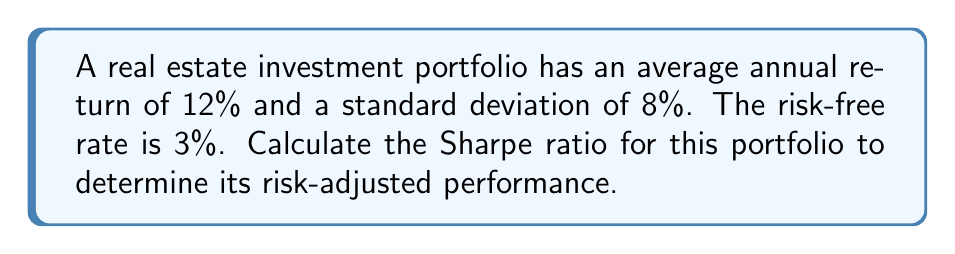Give your solution to this math problem. To calculate the Sharpe ratio, we need to follow these steps:

1. Identify the components:
   - Portfolio return ($R_p$) = 12%
   - Risk-free rate ($R_f$) = 3%
   - Portfolio standard deviation ($\sigma_p$) = 8%

2. Calculate the excess return:
   Excess return = $R_p - R_f = 12\% - 3\% = 9\%$

3. Apply the Sharpe ratio formula:
   $$\text{Sharpe Ratio} = \frac{R_p - R_f}{\sigma_p}$$

4. Substitute the values:
   $$\text{Sharpe Ratio} = \frac{12\% - 3\%}{8\%} = \frac{9\%}{8\%} = 1.125$$

5. Interpret the result:
   A Sharpe ratio of 1.125 indicates that for every unit of risk (standard deviation) taken, the portfolio generates 1.125 units of excess return above the risk-free rate.
Answer: 1.125 